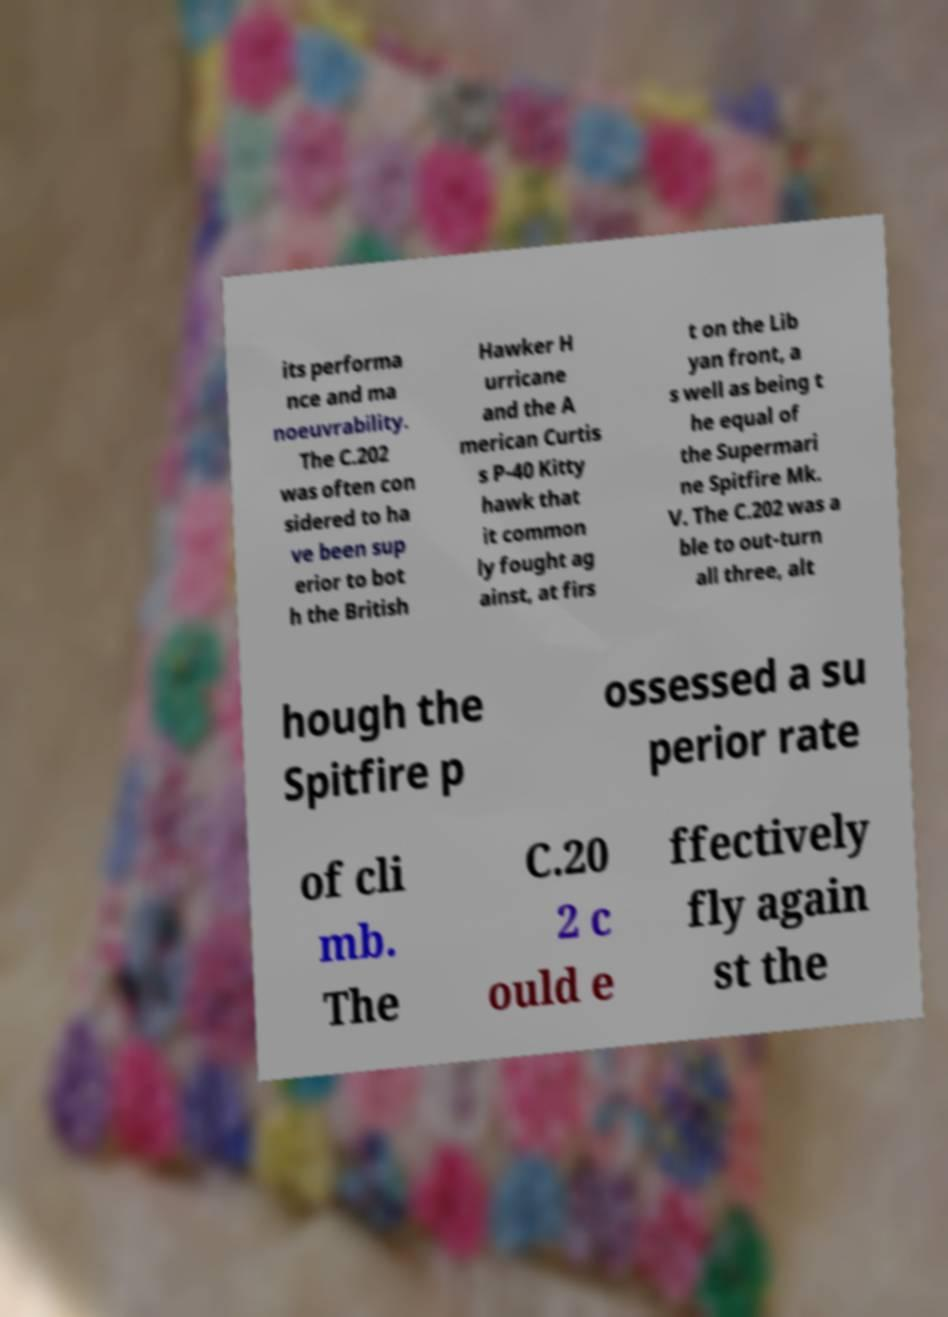Please read and relay the text visible in this image. What does it say? its performa nce and ma noeuvrability. The C.202 was often con sidered to ha ve been sup erior to bot h the British Hawker H urricane and the A merican Curtis s P-40 Kitty hawk that it common ly fought ag ainst, at firs t on the Lib yan front, a s well as being t he equal of the Supermari ne Spitfire Mk. V. The C.202 was a ble to out-turn all three, alt hough the Spitfire p ossessed a su perior rate of cli mb. The C.20 2 c ould e ffectively fly again st the 